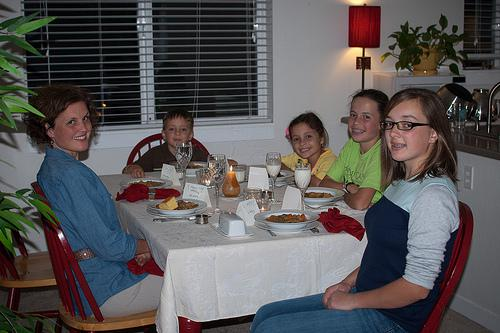Question: what are the people doing?
Choices:
A. Reading.
B. Snorkeling.
C. Eating.
D. Driving.
Answer with the letter. Answer: C Question: when is this picture taken?
Choices:
A. Dinner time.
B. Night.
C. Supper.
D. Noon.
Answer with the letter. Answer: A Question: why are the people smiling?
Choices:
A. For the picture.
B. The surprise party.
C. They won.
D. They are celebrating.
Answer with the letter. Answer: A Question: where is this picture taken?
Choices:
A. The dinner table.
B. The living room.
C. The bathroom.
D. The back yard.
Answer with the letter. Answer: A Question: how many people are in the picture?
Choices:
A. Four.
B. Five.
C. Three.
D. Six.
Answer with the letter. Answer: B Question: who is wearing a blue shirt?
Choices:
A. The boy.
B. The girl.
C. The woman on the left.
D. The baby.
Answer with the letter. Answer: C 